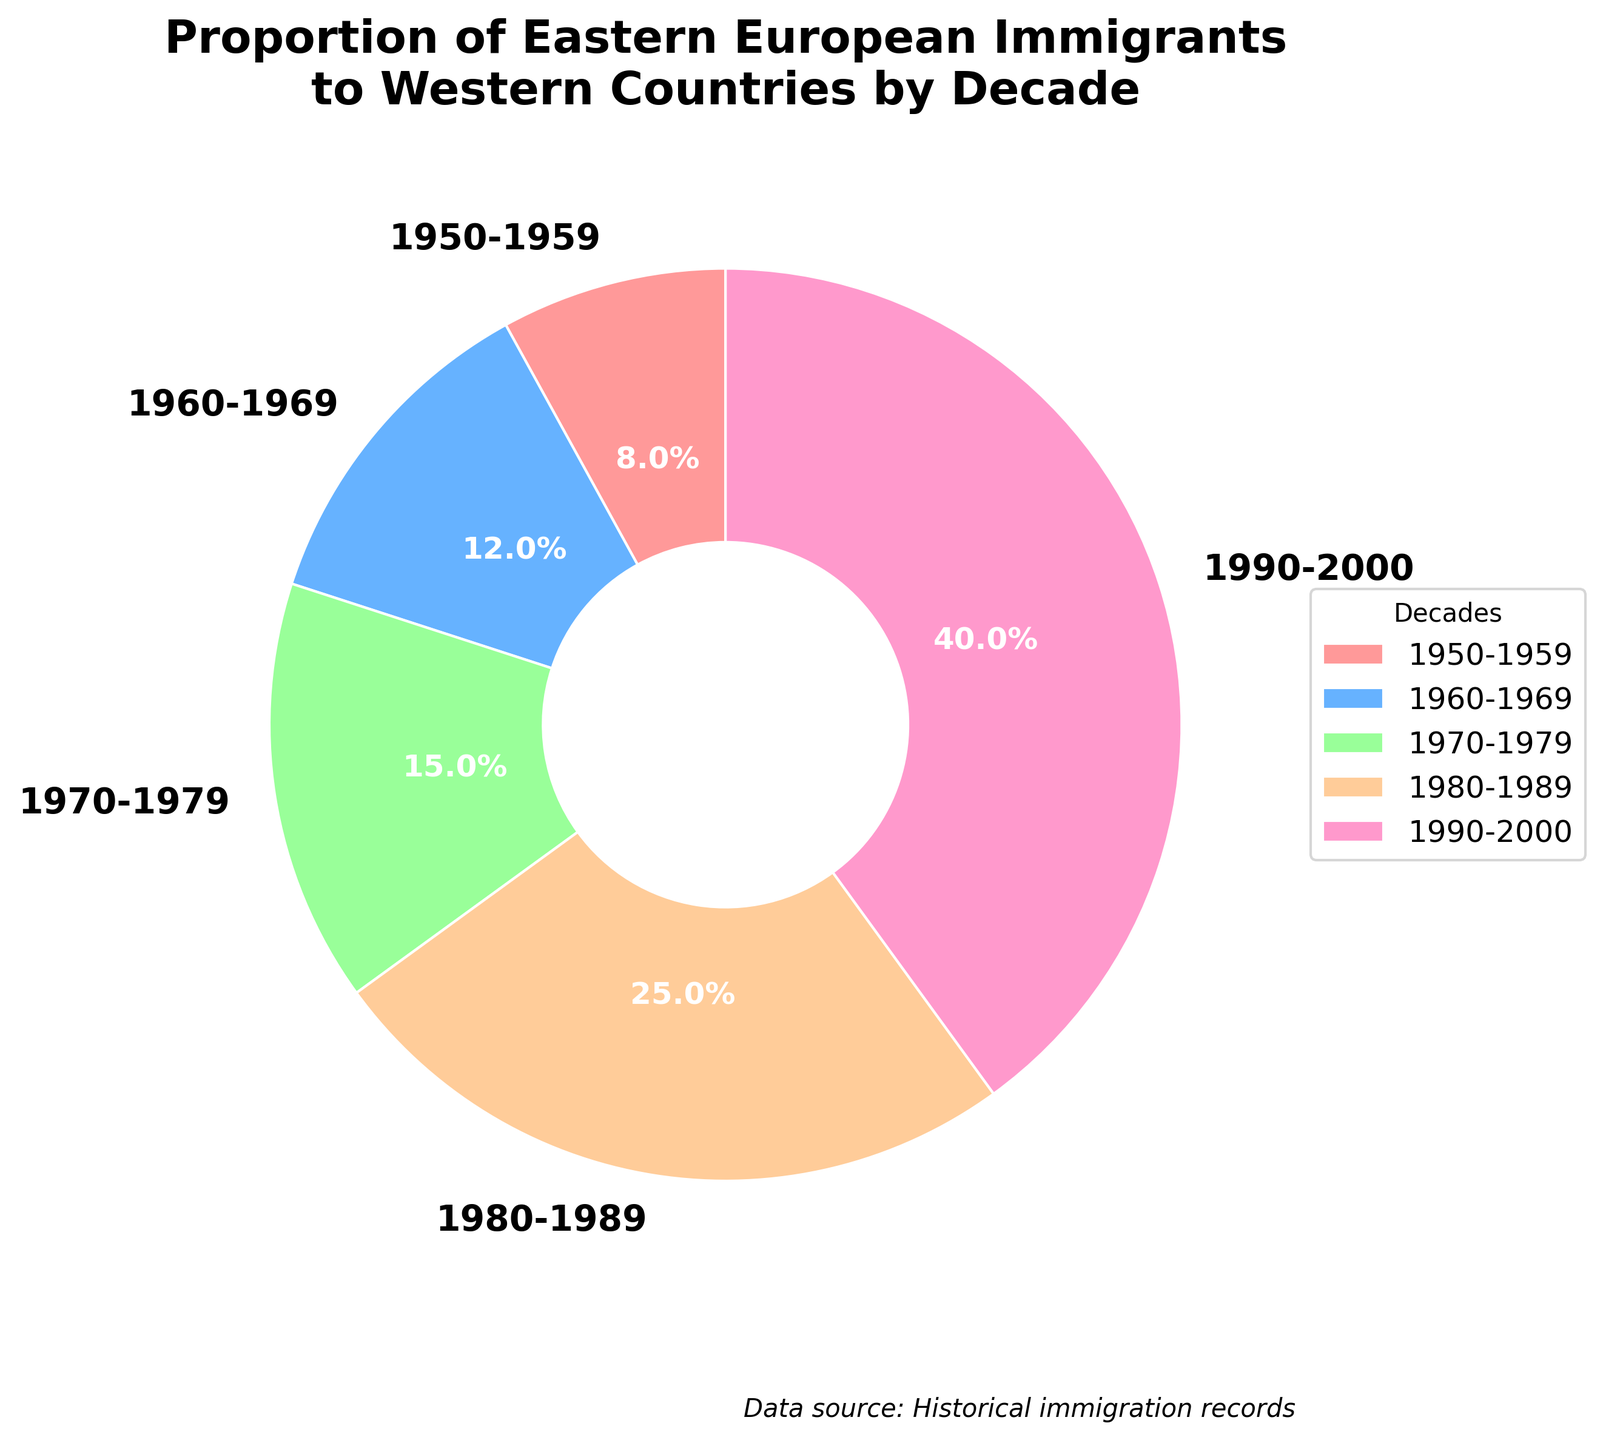What is the trend in the proportion of Eastern European immigrants to Western countries over the decades? The chart shows an increasing trend in the proportion of Eastern European immigrants from 1950-2000, starting at 0.08 in 1950-1959 and rising to 0.40 in 1990-2000.
Answer: Increasing Which decade witnessed the greatest increase in the proportion of Eastern European immigrants compared to the previous decade? By comparing the slices of the pie chart, we can see that the 1980-1989 decade had a significant increase compared to the previous decade (1970-1979), rising from 0.15 to 0.25, an increase of 0.10.
Answer: 1980-1989 What is the combined proportion of immigrants from the three decades between 1960 and 1989? Summing the proportions for 1960-1969 (0.12), 1970-1979 (0.15), and 1980-1989 (0.25), we get 0.12 + 0.15 + 0.25 = 0.52.
Answer: 0.52 Which slice of the pie is represented by the darkest shade? The wedge corresponding to the 1950-1959 decade is represented by the darkest shade on the pie chart.
Answer: 1950-1959 What proportion of the total immigrants did the last two decades (1980-2000) account for? Adding the proportions for 1980-1989 (0.25) and 1990-2000 (0.40), we get 0.25 + 0.40 = 0.65.
Answer: 0.65 By how much did the proportion increase from the first decade to the last decade? The proportion increased from 0.08 in 1950-1959 to 0.40 in 1990-2000. The difference is 0.40 - 0.08 = 0.32.
Answer: 0.32 Which decade had the smallest proportion of Eastern European immigrants? The 1950-1959 decade had the smallest proportion, with a value of 0.08.
Answer: 1950-1959 What is the average proportion of immigrants over the five decades? Adding the proportions for all five decades (0.08, 0.12, 0.15, 0.25, 0.40) and dividing by 5, (0.08 + 0.12 + 0.15 + 0.25 + 0.40) / 5 = 1.0 / 5 = 0.20.
Answer: 0.20 Which decades have a proportion greater than 0.10? The pie chart shows that 1960-1969 (0.12), 1970-1979 (0.15), 1980-1989 (0.25), and 1990-2000 (0.40) all have proportions greater than 0.10.
Answer: 1960-1969, 1970-1979, 1980-1989, 1990-2000 How does the proportion of the 1980-1989 decade compare to that of the 1970-1979 decade? The proportion in 1980-1989 (0.25) is larger than in 1970-1979 (0.15). The difference is 0.25 - 0.15 = 0.10.
Answer: Larger by 0.10 